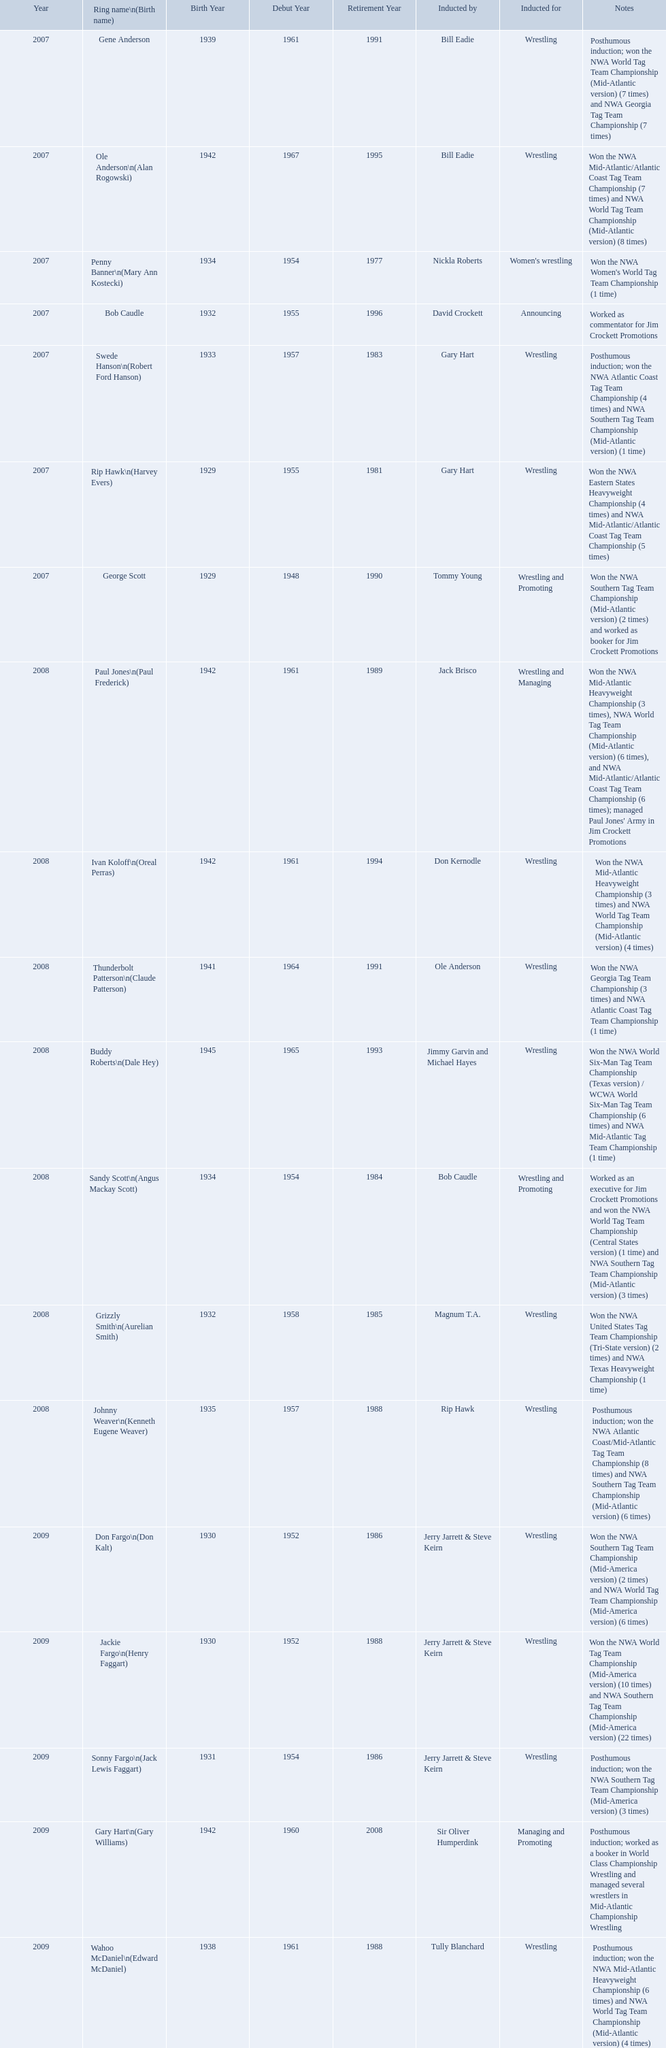Find the word(s) posthumous in the notes column. Posthumous induction; won the NWA World Tag Team Championship (Mid-Atlantic version) (7 times) and NWA Georgia Tag Team Championship (7 times), Posthumous induction; won the NWA Atlantic Coast Tag Team Championship (4 times) and NWA Southern Tag Team Championship (Mid-Atlantic version) (1 time), Posthumous induction; won the NWA Atlantic Coast/Mid-Atlantic Tag Team Championship (8 times) and NWA Southern Tag Team Championship (Mid-Atlantic version) (6 times), Posthumous induction; won the NWA Southern Tag Team Championship (Mid-America version) (3 times), Posthumous induction; worked as a booker in World Class Championship Wrestling and managed several wrestlers in Mid-Atlantic Championship Wrestling, Posthumous induction; won the NWA Mid-Atlantic Heavyweight Championship (6 times) and NWA World Tag Team Championship (Mid-Atlantic version) (4 times). What is the earliest year in the table that wrestlers were inducted? 2007, 2007, 2007, 2007, 2007, 2007, 2007. Find the wrestlers that wrestled underneath their birth name in the earliest year of induction. Gene Anderson, Bob Caudle, George Scott. Of the wrestlers who wrestled underneath their birth name in the earliest year of induction was one of them inducted posthumously? Gene Anderson. Help me parse the entirety of this table. {'header': ['Year', 'Ring name\\n(Birth name)', 'Birth Year', 'Debut Year', 'Retirement Year', 'Inducted by', 'Inducted for', 'Notes'], 'rows': [['2007', 'Gene Anderson', '1939', '1961', '1991', 'Bill Eadie', 'Wrestling', 'Posthumous induction; won the NWA World Tag Team Championship (Mid-Atlantic version) (7 times) and NWA Georgia Tag Team Championship (7 times)'], ['2007', 'Ole Anderson\\n(Alan Rogowski)', '1942', '1967', '1995', 'Bill Eadie', 'Wrestling', 'Won the NWA Mid-Atlantic/Atlantic Coast Tag Team Championship (7 times) and NWA World Tag Team Championship (Mid-Atlantic version) (8 times)'], ['2007', 'Penny Banner\\n(Mary Ann Kostecki)', '1934', '1954', '1977', 'Nickla Roberts', "Women's wrestling", "Won the NWA Women's World Tag Team Championship (1 time)"], ['2007', 'Bob Caudle', '1932', '1955', '1996', 'David Crockett', 'Announcing', 'Worked as commentator for Jim Crockett Promotions'], ['2007', 'Swede Hanson\\n(Robert Ford Hanson)', '1933', '1957', '1983', 'Gary Hart', 'Wrestling', 'Posthumous induction; won the NWA Atlantic Coast Tag Team Championship (4 times) and NWA Southern Tag Team Championship (Mid-Atlantic version) (1 time)'], ['2007', 'Rip Hawk\\n(Harvey Evers)', '1929', '1955', '1981', 'Gary Hart', 'Wrestling', 'Won the NWA Eastern States Heavyweight Championship (4 times) and NWA Mid-Atlantic/Atlantic Coast Tag Team Championship (5 times)'], ['2007', 'George Scott', '1929', '1948', '1990', 'Tommy Young', 'Wrestling and Promoting', 'Won the NWA Southern Tag Team Championship (Mid-Atlantic version) (2 times) and worked as booker for Jim Crockett Promotions'], ['2008', 'Paul Jones\\n(Paul Frederick)', '1942', '1961', '1989', 'Jack Brisco', 'Wrestling and Managing', "Won the NWA Mid-Atlantic Heavyweight Championship (3 times), NWA World Tag Team Championship (Mid-Atlantic version) (6 times), and NWA Mid-Atlantic/Atlantic Coast Tag Team Championship (6 times); managed Paul Jones' Army in Jim Crockett Promotions"], ['2008', 'Ivan Koloff\\n(Oreal Perras)', '1942', '1961', '1994', 'Don Kernodle', 'Wrestling', 'Won the NWA Mid-Atlantic Heavyweight Championship (3 times) and NWA World Tag Team Championship (Mid-Atlantic version) (4 times)'], ['2008', 'Thunderbolt Patterson\\n(Claude Patterson)', '1941', '1964', '1991', 'Ole Anderson', 'Wrestling', 'Won the NWA Georgia Tag Team Championship (3 times) and NWA Atlantic Coast Tag Team Championship (1 time)'], ['2008', 'Buddy Roberts\\n(Dale Hey)', '1945', '1965', '1993', 'Jimmy Garvin and Michael Hayes', 'Wrestling', 'Won the NWA World Six-Man Tag Team Championship (Texas version) / WCWA World Six-Man Tag Team Championship (6 times) and NWA Mid-Atlantic Tag Team Championship (1 time)'], ['2008', 'Sandy Scott\\n(Angus Mackay Scott)', '1934', '1954', '1984', 'Bob Caudle', 'Wrestling and Promoting', 'Worked as an executive for Jim Crockett Promotions and won the NWA World Tag Team Championship (Central States version) (1 time) and NWA Southern Tag Team Championship (Mid-Atlantic version) (3 times)'], ['2008', 'Grizzly Smith\\n(Aurelian Smith)', '1932', '1958', '1985', 'Magnum T.A.', 'Wrestling', 'Won the NWA United States Tag Team Championship (Tri-State version) (2 times) and NWA Texas Heavyweight Championship (1 time)'], ['2008', 'Johnny Weaver\\n(Kenneth Eugene Weaver)', '1935', '1957', '1988', 'Rip Hawk', 'Wrestling', 'Posthumous induction; won the NWA Atlantic Coast/Mid-Atlantic Tag Team Championship (8 times) and NWA Southern Tag Team Championship (Mid-Atlantic version) (6 times)'], ['2009', 'Don Fargo\\n(Don Kalt)', '1930', '1952', '1986', 'Jerry Jarrett & Steve Keirn', 'Wrestling', 'Won the NWA Southern Tag Team Championship (Mid-America version) (2 times) and NWA World Tag Team Championship (Mid-America version) (6 times)'], ['2009', 'Jackie Fargo\\n(Henry Faggart)', '1930', '1952', '1988', 'Jerry Jarrett & Steve Keirn', 'Wrestling', 'Won the NWA World Tag Team Championship (Mid-America version) (10 times) and NWA Southern Tag Team Championship (Mid-America version) (22 times)'], ['2009', 'Sonny Fargo\\n(Jack Lewis Faggart)', '1931', '1954', '1986', 'Jerry Jarrett & Steve Keirn', 'Wrestling', 'Posthumous induction; won the NWA Southern Tag Team Championship (Mid-America version) (3 times)'], ['2009', 'Gary Hart\\n(Gary Williams)', '1942', '1960', '2008', 'Sir Oliver Humperdink', 'Managing and Promoting', 'Posthumous induction; worked as a booker in World Class Championship Wrestling and managed several wrestlers in Mid-Atlantic Championship Wrestling'], ['2009', 'Wahoo McDaniel\\n(Edward McDaniel)', '1938', '1961', '1988', 'Tully Blanchard', 'Wrestling', 'Posthumous induction; won the NWA Mid-Atlantic Heavyweight Championship (6 times) and NWA World Tag Team Championship (Mid-Atlantic version) (4 times)'], ['2009', 'Blackjack Mulligan\\n(Robert Windham)', '1942', '1967', '1989', 'Ric Flair', 'Wrestling', 'Won the NWA Texas Heavyweight Championship (1 time) and NWA World Tag Team Championship (Mid-Atlantic version) (1 time)'], ['2009', 'Nelson Royal', '1935', '1963', '1997', 'Brad Anderson, Tommy Angel & David Isley', 'Wrestling', 'Won the NWA Atlantic Coast Tag Team Championship (2 times)'], ['2009', 'Lance Russell', '1926', '1959', '2001', 'Dave Brown', 'Announcing', 'Worked as commentator for wrestling events in the Memphis area']]} Could you help me parse every detail presented in this table? {'header': ['Year', 'Ring name\\n(Birth name)', 'Birth Year', 'Debut Year', 'Retirement Year', 'Inducted by', 'Inducted for', 'Notes'], 'rows': [['2007', 'Gene Anderson', '1939', '1961', '1991', 'Bill Eadie', 'Wrestling', 'Posthumous induction; won the NWA World Tag Team Championship (Mid-Atlantic version) (7 times) and NWA Georgia Tag Team Championship (7 times)'], ['2007', 'Ole Anderson\\n(Alan Rogowski)', '1942', '1967', '1995', 'Bill Eadie', 'Wrestling', 'Won the NWA Mid-Atlantic/Atlantic Coast Tag Team Championship (7 times) and NWA World Tag Team Championship (Mid-Atlantic version) (8 times)'], ['2007', 'Penny Banner\\n(Mary Ann Kostecki)', '1934', '1954', '1977', 'Nickla Roberts', "Women's wrestling", "Won the NWA Women's World Tag Team Championship (1 time)"], ['2007', 'Bob Caudle', '1932', '1955', '1996', 'David Crockett', 'Announcing', 'Worked as commentator for Jim Crockett Promotions'], ['2007', 'Swede Hanson\\n(Robert Ford Hanson)', '1933', '1957', '1983', 'Gary Hart', 'Wrestling', 'Posthumous induction; won the NWA Atlantic Coast Tag Team Championship (4 times) and NWA Southern Tag Team Championship (Mid-Atlantic version) (1 time)'], ['2007', 'Rip Hawk\\n(Harvey Evers)', '1929', '1955', '1981', 'Gary Hart', 'Wrestling', 'Won the NWA Eastern States Heavyweight Championship (4 times) and NWA Mid-Atlantic/Atlantic Coast Tag Team Championship (5 times)'], ['2007', 'George Scott', '1929', '1948', '1990', 'Tommy Young', 'Wrestling and Promoting', 'Won the NWA Southern Tag Team Championship (Mid-Atlantic version) (2 times) and worked as booker for Jim Crockett Promotions'], ['2008', 'Paul Jones\\n(Paul Frederick)', '1942', '1961', '1989', 'Jack Brisco', 'Wrestling and Managing', "Won the NWA Mid-Atlantic Heavyweight Championship (3 times), NWA World Tag Team Championship (Mid-Atlantic version) (6 times), and NWA Mid-Atlantic/Atlantic Coast Tag Team Championship (6 times); managed Paul Jones' Army in Jim Crockett Promotions"], ['2008', 'Ivan Koloff\\n(Oreal Perras)', '1942', '1961', '1994', 'Don Kernodle', 'Wrestling', 'Won the NWA Mid-Atlantic Heavyweight Championship (3 times) and NWA World Tag Team Championship (Mid-Atlantic version) (4 times)'], ['2008', 'Thunderbolt Patterson\\n(Claude Patterson)', '1941', '1964', '1991', 'Ole Anderson', 'Wrestling', 'Won the NWA Georgia Tag Team Championship (3 times) and NWA Atlantic Coast Tag Team Championship (1 time)'], ['2008', 'Buddy Roberts\\n(Dale Hey)', '1945', '1965', '1993', 'Jimmy Garvin and Michael Hayes', 'Wrestling', 'Won the NWA World Six-Man Tag Team Championship (Texas version) / WCWA World Six-Man Tag Team Championship (6 times) and NWA Mid-Atlantic Tag Team Championship (1 time)'], ['2008', 'Sandy Scott\\n(Angus Mackay Scott)', '1934', '1954', '1984', 'Bob Caudle', 'Wrestling and Promoting', 'Worked as an executive for Jim Crockett Promotions and won the NWA World Tag Team Championship (Central States version) (1 time) and NWA Southern Tag Team Championship (Mid-Atlantic version) (3 times)'], ['2008', 'Grizzly Smith\\n(Aurelian Smith)', '1932', '1958', '1985', 'Magnum T.A.', 'Wrestling', 'Won the NWA United States Tag Team Championship (Tri-State version) (2 times) and NWA Texas Heavyweight Championship (1 time)'], ['2008', 'Johnny Weaver\\n(Kenneth Eugene Weaver)', '1935', '1957', '1988', 'Rip Hawk', 'Wrestling', 'Posthumous induction; won the NWA Atlantic Coast/Mid-Atlantic Tag Team Championship (8 times) and NWA Southern Tag Team Championship (Mid-Atlantic version) (6 times)'], ['2009', 'Don Fargo\\n(Don Kalt)', '1930', '1952', '1986', 'Jerry Jarrett & Steve Keirn', 'Wrestling', 'Won the NWA Southern Tag Team Championship (Mid-America version) (2 times) and NWA World Tag Team Championship (Mid-America version) (6 times)'], ['2009', 'Jackie Fargo\\n(Henry Faggart)', '1930', '1952', '1988', 'Jerry Jarrett & Steve Keirn', 'Wrestling', 'Won the NWA World Tag Team Championship (Mid-America version) (10 times) and NWA Southern Tag Team Championship (Mid-America version) (22 times)'], ['2009', 'Sonny Fargo\\n(Jack Lewis Faggart)', '1931', '1954', '1986', 'Jerry Jarrett & Steve Keirn', 'Wrestling', 'Posthumous induction; won the NWA Southern Tag Team Championship (Mid-America version) (3 times)'], ['2009', 'Gary Hart\\n(Gary Williams)', '1942', '1960', '2008', 'Sir Oliver Humperdink', 'Managing and Promoting', 'Posthumous induction; worked as a booker in World Class Championship Wrestling and managed several wrestlers in Mid-Atlantic Championship Wrestling'], ['2009', 'Wahoo McDaniel\\n(Edward McDaniel)', '1938', '1961', '1988', 'Tully Blanchard', 'Wrestling', 'Posthumous induction; won the NWA Mid-Atlantic Heavyweight Championship (6 times) and NWA World Tag Team Championship (Mid-Atlantic version) (4 times)'], ['2009', 'Blackjack Mulligan\\n(Robert Windham)', '1942', '1967', '1989', 'Ric Flair', 'Wrestling', 'Won the NWA Texas Heavyweight Championship (1 time) and NWA World Tag Team Championship (Mid-Atlantic version) (1 time)'], ['2009', 'Nelson Royal', '1935', '1963', '1997', 'Brad Anderson, Tommy Angel & David Isley', 'Wrestling', 'Won the NWA Atlantic Coast Tag Team Championship (2 times)'], ['2009', 'Lance Russell', '1926', '1959', '2001', 'Dave Brown', 'Announcing', 'Worked as commentator for wrestling events in the Memphis area']]} What were all the wrestler's ring names? Gene Anderson, Ole Anderson\n(Alan Rogowski), Penny Banner\n(Mary Ann Kostecki), Bob Caudle, Swede Hanson\n(Robert Ford Hanson), Rip Hawk\n(Harvey Evers), George Scott, Paul Jones\n(Paul Frederick), Ivan Koloff\n(Oreal Perras), Thunderbolt Patterson\n(Claude Patterson), Buddy Roberts\n(Dale Hey), Sandy Scott\n(Angus Mackay Scott), Grizzly Smith\n(Aurelian Smith), Johnny Weaver\n(Kenneth Eugene Weaver), Don Fargo\n(Don Kalt), Jackie Fargo\n(Henry Faggart), Sonny Fargo\n(Jack Lewis Faggart), Gary Hart\n(Gary Williams), Wahoo McDaniel\n(Edward McDaniel), Blackjack Mulligan\n(Robert Windham), Nelson Royal, Lance Russell. Besides bob caudle, who was an announcer? Lance Russell. 